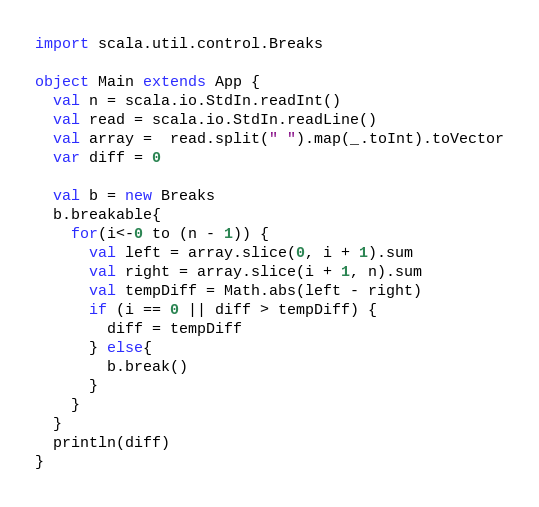<code> <loc_0><loc_0><loc_500><loc_500><_Scala_>import scala.util.control.Breaks

object Main extends App {
  val n = scala.io.StdIn.readInt()
  val read = scala.io.StdIn.readLine()
  val array =  read.split(" ").map(_.toInt).toVector
  var diff = 0

  val b = new Breaks
  b.breakable{
    for(i<-0 to (n - 1)) {
      val left = array.slice(0, i + 1).sum
      val right = array.slice(i + 1, n).sum
      val tempDiff = Math.abs(left - right)
      if (i == 0 || diff > tempDiff) {
        diff = tempDiff
      } else{
        b.break()
      }
    }
  }
  println(diff)
}</code> 